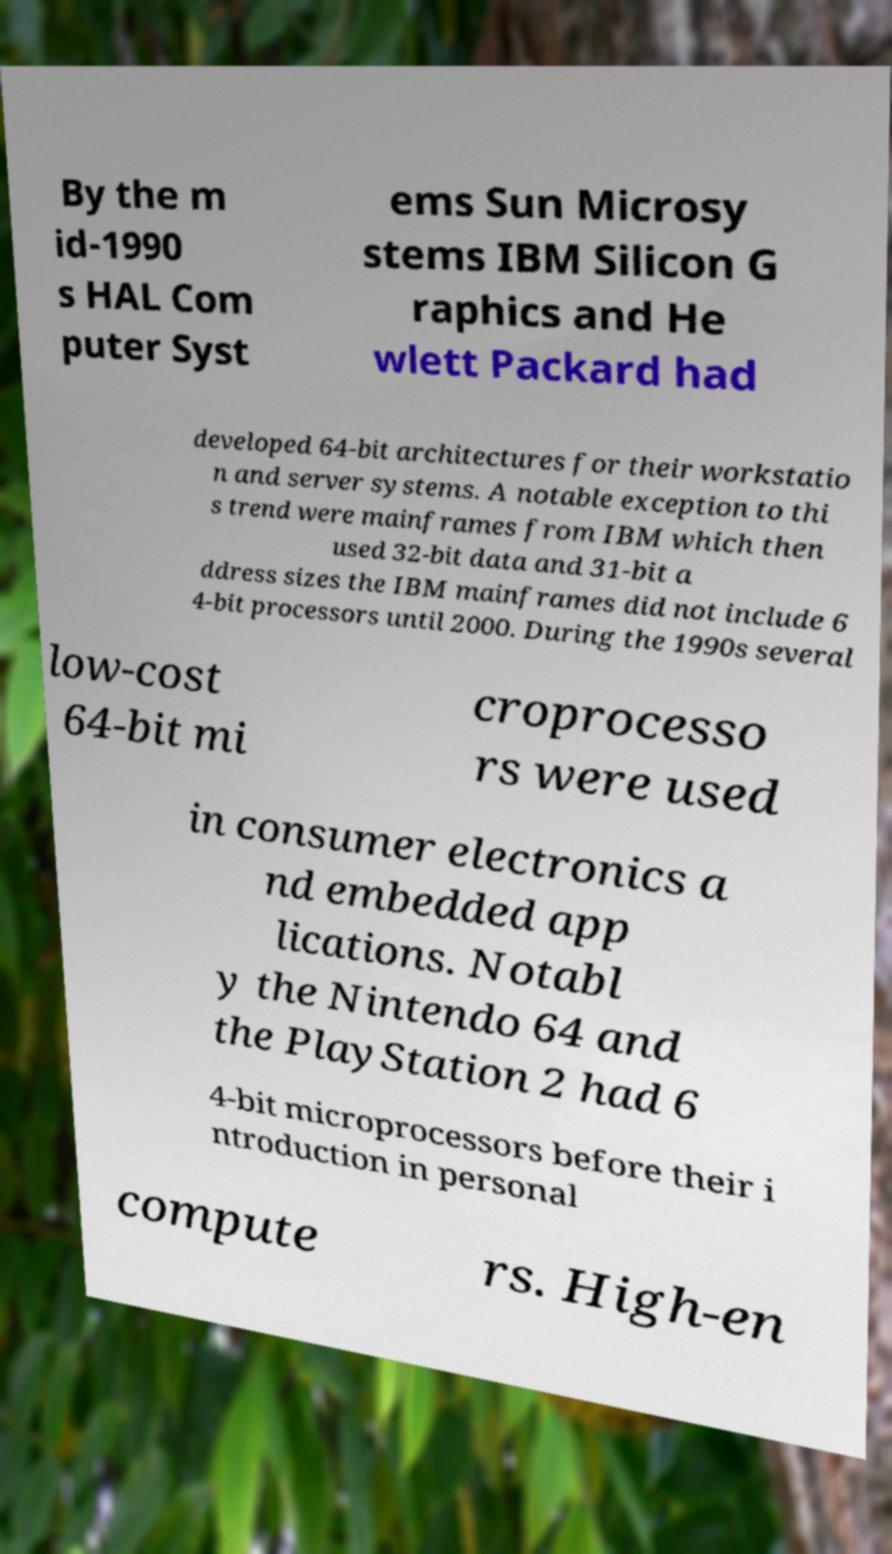Can you read and provide the text displayed in the image?This photo seems to have some interesting text. Can you extract and type it out for me? By the m id-1990 s HAL Com puter Syst ems Sun Microsy stems IBM Silicon G raphics and He wlett Packard had developed 64-bit architectures for their workstatio n and server systems. A notable exception to thi s trend were mainframes from IBM which then used 32-bit data and 31-bit a ddress sizes the IBM mainframes did not include 6 4-bit processors until 2000. During the 1990s several low-cost 64-bit mi croprocesso rs were used in consumer electronics a nd embedded app lications. Notabl y the Nintendo 64 and the PlayStation 2 had 6 4-bit microprocessors before their i ntroduction in personal compute rs. High-en 